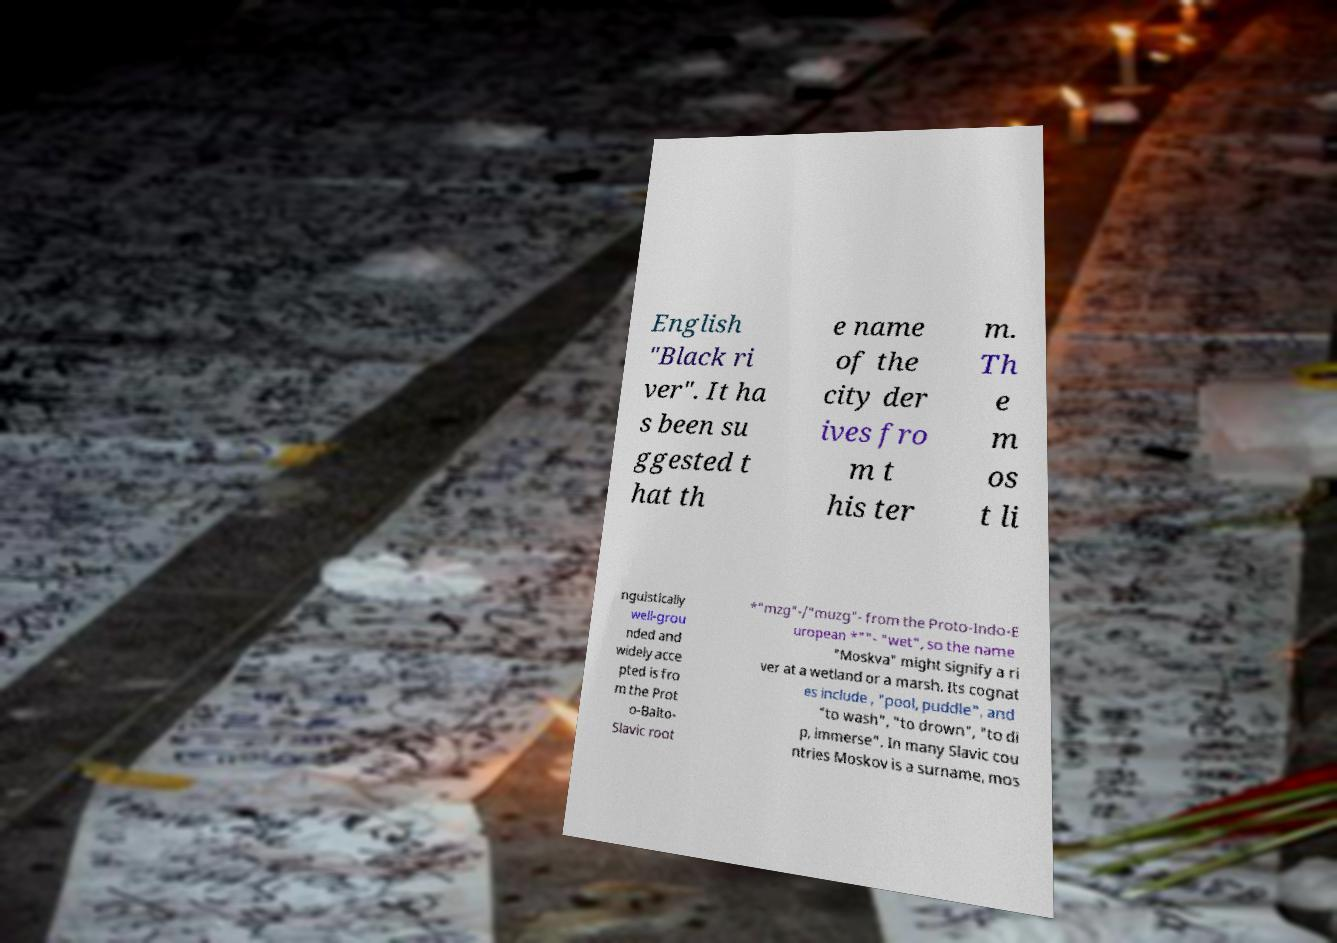Please read and relay the text visible in this image. What does it say? English "Black ri ver". It ha s been su ggested t hat th e name of the city der ives fro m t his ter m. Th e m os t li nguistically well-grou nded and widely acce pted is fro m the Prot o-Balto- Slavic root *"mzg"-/"muzg"- from the Proto-Indo-E uropean *""- "wet", so the name "Moskva" might signify a ri ver at a wetland or a marsh. Its cognat es include , "pool, puddle", and "to wash", "to drown", "to di p, immerse". In many Slavic cou ntries Moskov is a surname, mos 